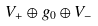<formula> <loc_0><loc_0><loc_500><loc_500>V _ { + } \oplus g _ { 0 } \oplus V _ { - }</formula> 